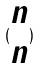Convert formula to latex. <formula><loc_0><loc_0><loc_500><loc_500>( \begin{matrix} n \\ n \end{matrix} )</formula> 